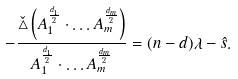Convert formula to latex. <formula><loc_0><loc_0><loc_500><loc_500>- \frac { \check { \triangle } \left ( A _ { 1 } ^ { \frac { d _ { 1 } } { 2 } } \cdot \dots A _ { m } ^ { \frac { d _ { m } } { 2 } } \right ) } { A _ { 1 } ^ { \frac { d _ { 1 } } { 2 } } \cdot \dots A _ { m } ^ { \frac { d _ { m } } { 2 } } } = ( n - d ) \lambda - \hat { s } .</formula> 